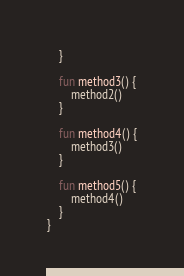<code> <loc_0><loc_0><loc_500><loc_500><_Kotlin_>    }

    fun method3() {
        method2()
    }

    fun method4() {
        method3()
    }

    fun method5() {
        method4()
    }
}
</code> 